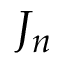Convert formula to latex. <formula><loc_0><loc_0><loc_500><loc_500>J _ { n }</formula> 